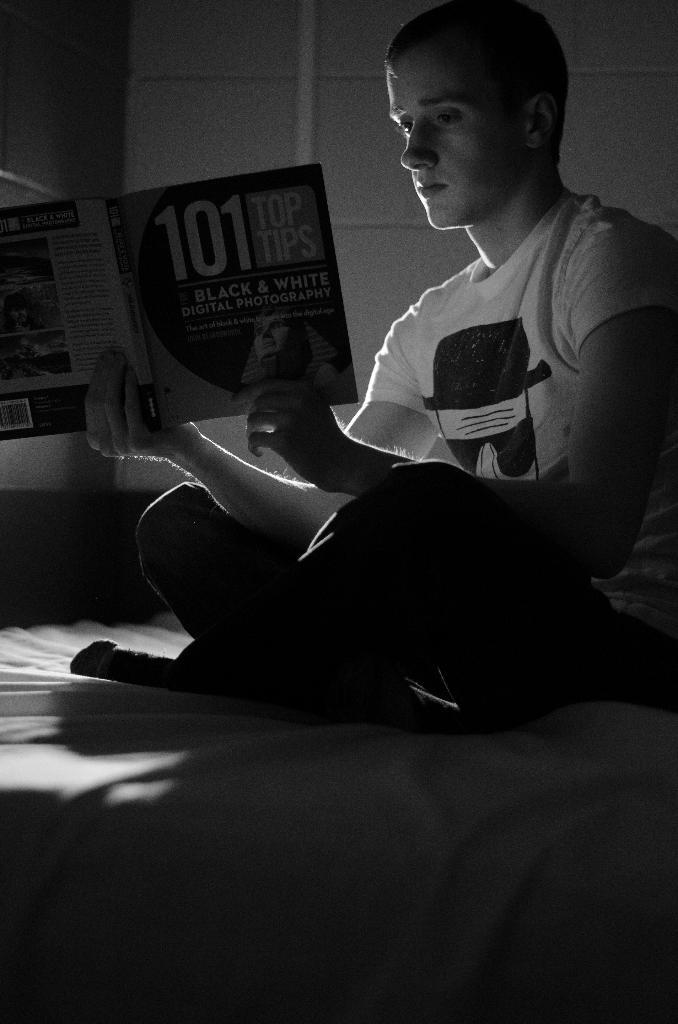Who is present in the image? There is a person in the image. What is the person doing in the image? The person is sitting on a bed and reading a book. What type of vessel is being used to illuminate the room in the image? There is no vessel or light source present in the image; the person is reading a book in a well-lit environment. 